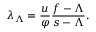Convert formula to latex. <formula><loc_0><loc_0><loc_500><loc_500>\lambda _ { \Lambda } = \frac { u } { \varphi } \frac { f - \Lambda } { s - \Lambda } .</formula> 